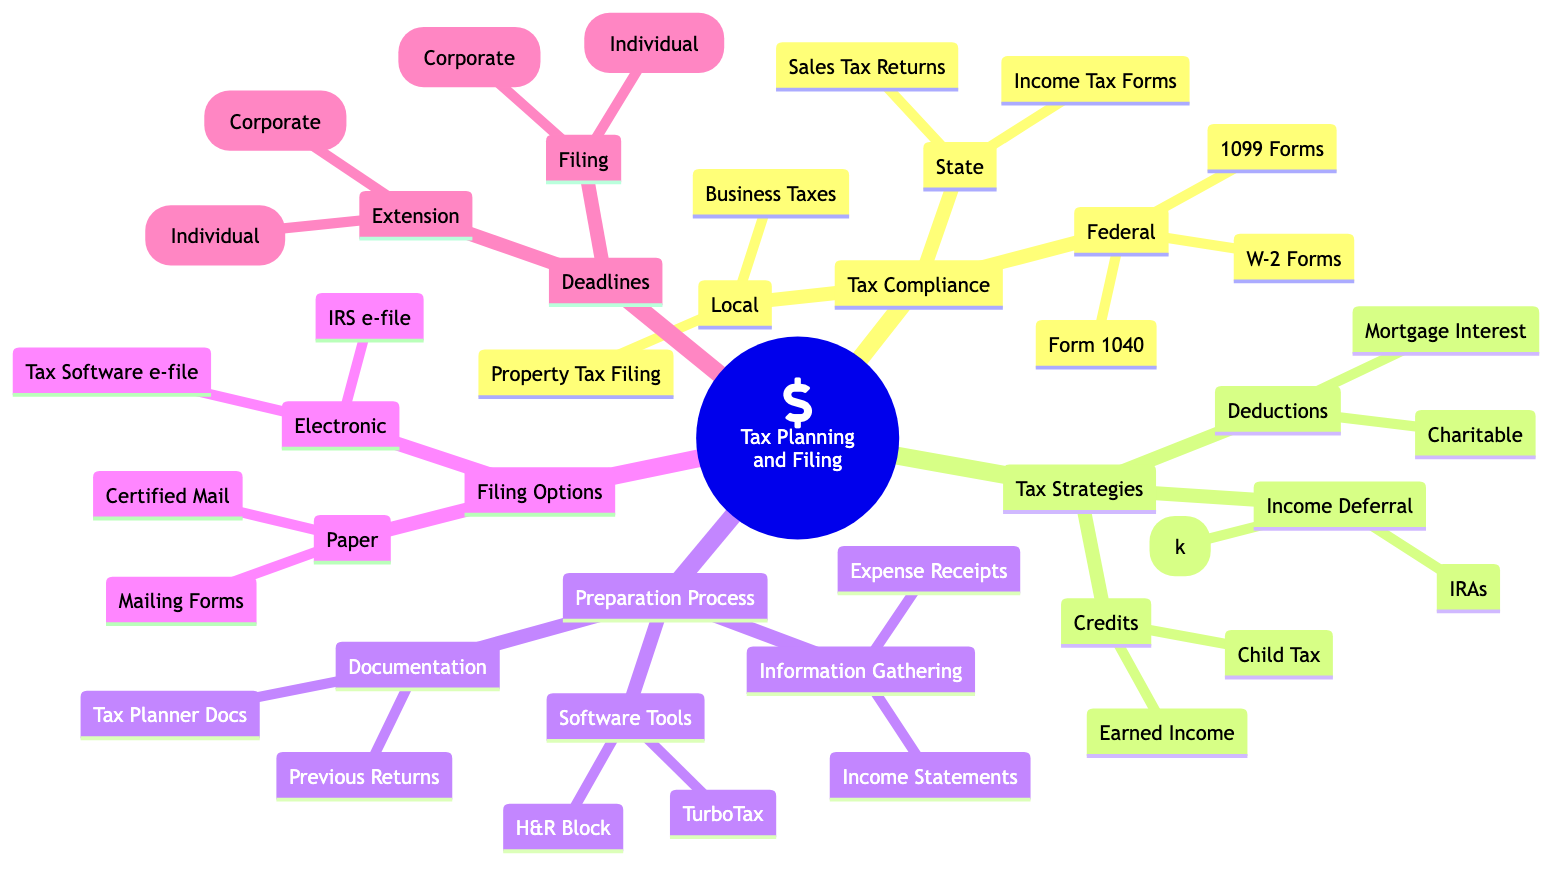What are the two types of tax compliance mentioned in the diagram? The diagram lists three categories of tax compliance: Federal, State, and Local. Hence, any two types could be Federal, State, or Local. The specific question asks for two types, so Federal and State are valid answers.
Answer: Federal, State How many filing options are listed in the diagram? The diagram shows two main filing options: Electronic Filing and Paper Filing. Hence, counting them gives a total of two options.
Answer: 2 What is one of the tax credits mentioned in the diagram? Within the Tax Strategies section, under Credits, the diagram mentions Earned Income Credit and Child Tax Credit. Therefore, either of these is a valid answer.
Answer: Earned Income Credit Which document is required for Federal Tax Compliance? Under Tax Compliance and the Federal category, the diagram identifies specific forms like Form 1040, W-2 Forms, and 1099 Forms. To directly answer the question, any of these forms would be valid.
Answer: Form 1040 What is the filing deadline for individuals? The diagram specifies April 15th as the filing deadline for individuals under the Deadlines section. Therefore, this date directly answers the question.
Answer: April 15th What are the two subcategories of Tax Strategies? The Tax Strategies section of the diagram contains three subcategories: Income Deferral, Deductions, and Credits. However, to answer the question, any two of these subcategories would suffice, such as Income Deferral and Deductions.
Answer: Income Deferral, Deductions When is the extension deadline for corporate tax filing? Referencing the Deadlines section, the diagram indicates September 15th as the extension deadline for corporate tax filing. This directly answers the question about corporate extensions.
Answer: September 15th What is required during the Information Gathering process? The Preparation Process section lists Income Statements and Expense Receipts under Information Gathering. The question asks for any of these, and both are valid answers.
Answer: Income Statements, Expense Receipts 